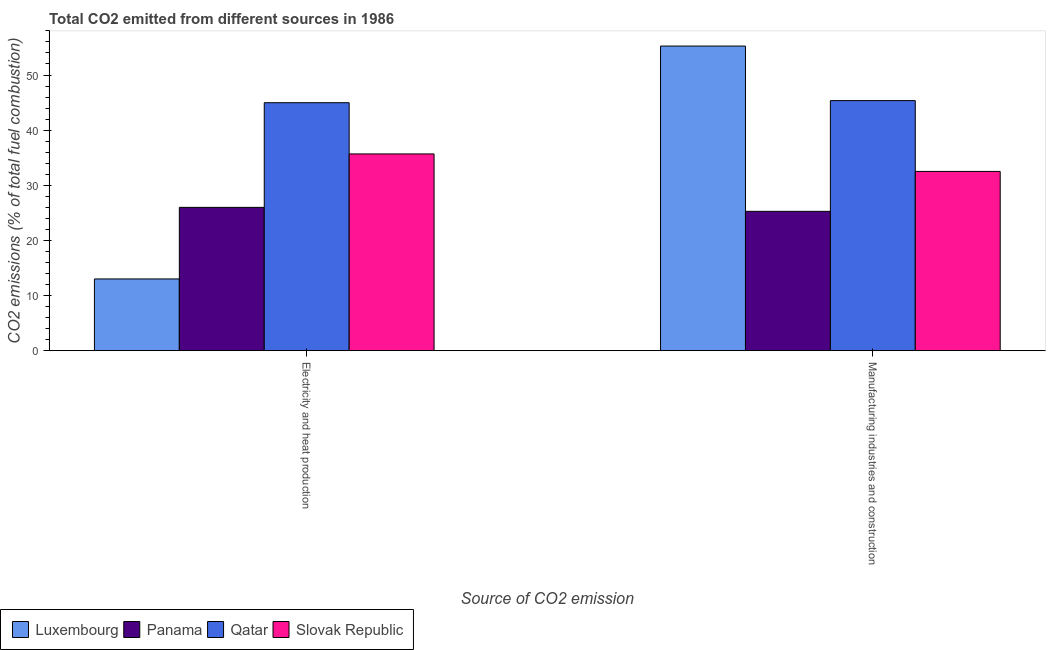How many different coloured bars are there?
Provide a succinct answer. 4. How many groups of bars are there?
Keep it short and to the point. 2. Are the number of bars per tick equal to the number of legend labels?
Ensure brevity in your answer.  Yes. What is the label of the 1st group of bars from the left?
Ensure brevity in your answer.  Electricity and heat production. What is the co2 emissions due to electricity and heat production in Slovak Republic?
Your response must be concise. 35.69. Across all countries, what is the maximum co2 emissions due to electricity and heat production?
Make the answer very short. 44.98. Across all countries, what is the minimum co2 emissions due to electricity and heat production?
Keep it short and to the point. 13.01. In which country was the co2 emissions due to electricity and heat production maximum?
Offer a terse response. Qatar. In which country was the co2 emissions due to electricity and heat production minimum?
Keep it short and to the point. Luxembourg. What is the total co2 emissions due to manufacturing industries in the graph?
Ensure brevity in your answer.  158.4. What is the difference between the co2 emissions due to manufacturing industries in Qatar and that in Panama?
Your response must be concise. 20.09. What is the difference between the co2 emissions due to manufacturing industries in Luxembourg and the co2 emissions due to electricity and heat production in Slovak Republic?
Your answer should be very brief. 19.57. What is the average co2 emissions due to manufacturing industries per country?
Offer a very short reply. 39.6. What is the difference between the co2 emissions due to electricity and heat production and co2 emissions due to manufacturing industries in Qatar?
Your answer should be compact. -0.38. In how many countries, is the co2 emissions due to manufacturing industries greater than 16 %?
Keep it short and to the point. 4. What is the ratio of the co2 emissions due to electricity and heat production in Panama to that in Luxembourg?
Keep it short and to the point. 2. In how many countries, is the co2 emissions due to electricity and heat production greater than the average co2 emissions due to electricity and heat production taken over all countries?
Offer a terse response. 2. What does the 4th bar from the left in Electricity and heat production represents?
Your answer should be compact. Slovak Republic. What does the 3rd bar from the right in Electricity and heat production represents?
Your response must be concise. Panama. How many bars are there?
Your response must be concise. 8. Are all the bars in the graph horizontal?
Provide a succinct answer. No. Does the graph contain grids?
Provide a short and direct response. No. Where does the legend appear in the graph?
Provide a short and direct response. Bottom left. What is the title of the graph?
Provide a succinct answer. Total CO2 emitted from different sources in 1986. What is the label or title of the X-axis?
Your answer should be very brief. Source of CO2 emission. What is the label or title of the Y-axis?
Provide a short and direct response. CO2 emissions (% of total fuel combustion). What is the CO2 emissions (% of total fuel combustion) of Luxembourg in Electricity and heat production?
Keep it short and to the point. 13.01. What is the CO2 emissions (% of total fuel combustion) of Panama in Electricity and heat production?
Provide a short and direct response. 25.99. What is the CO2 emissions (% of total fuel combustion) of Qatar in Electricity and heat production?
Provide a short and direct response. 44.98. What is the CO2 emissions (% of total fuel combustion) in Slovak Republic in Electricity and heat production?
Provide a succinct answer. 35.69. What is the CO2 emissions (% of total fuel combustion) in Luxembourg in Manufacturing industries and construction?
Your answer should be very brief. 55.25. What is the CO2 emissions (% of total fuel combustion) in Panama in Manufacturing industries and construction?
Offer a terse response. 25.27. What is the CO2 emissions (% of total fuel combustion) of Qatar in Manufacturing industries and construction?
Give a very brief answer. 45.36. What is the CO2 emissions (% of total fuel combustion) of Slovak Republic in Manufacturing industries and construction?
Make the answer very short. 32.51. Across all Source of CO2 emission, what is the maximum CO2 emissions (% of total fuel combustion) of Luxembourg?
Give a very brief answer. 55.25. Across all Source of CO2 emission, what is the maximum CO2 emissions (% of total fuel combustion) of Panama?
Give a very brief answer. 25.99. Across all Source of CO2 emission, what is the maximum CO2 emissions (% of total fuel combustion) in Qatar?
Your answer should be compact. 45.36. Across all Source of CO2 emission, what is the maximum CO2 emissions (% of total fuel combustion) of Slovak Republic?
Give a very brief answer. 35.69. Across all Source of CO2 emission, what is the minimum CO2 emissions (% of total fuel combustion) in Luxembourg?
Keep it short and to the point. 13.01. Across all Source of CO2 emission, what is the minimum CO2 emissions (% of total fuel combustion) of Panama?
Your response must be concise. 25.27. Across all Source of CO2 emission, what is the minimum CO2 emissions (% of total fuel combustion) in Qatar?
Keep it short and to the point. 44.98. Across all Source of CO2 emission, what is the minimum CO2 emissions (% of total fuel combustion) in Slovak Republic?
Provide a succinct answer. 32.51. What is the total CO2 emissions (% of total fuel combustion) in Luxembourg in the graph?
Keep it short and to the point. 68.26. What is the total CO2 emissions (% of total fuel combustion) in Panama in the graph?
Make the answer very short. 51.26. What is the total CO2 emissions (% of total fuel combustion) of Qatar in the graph?
Provide a succinct answer. 90.33. What is the total CO2 emissions (% of total fuel combustion) of Slovak Republic in the graph?
Your answer should be very brief. 68.2. What is the difference between the CO2 emissions (% of total fuel combustion) of Luxembourg in Electricity and heat production and that in Manufacturing industries and construction?
Your response must be concise. -42.25. What is the difference between the CO2 emissions (% of total fuel combustion) in Panama in Electricity and heat production and that in Manufacturing industries and construction?
Offer a very short reply. 0.72. What is the difference between the CO2 emissions (% of total fuel combustion) of Qatar in Electricity and heat production and that in Manufacturing industries and construction?
Offer a very short reply. -0.38. What is the difference between the CO2 emissions (% of total fuel combustion) of Slovak Republic in Electricity and heat production and that in Manufacturing industries and construction?
Give a very brief answer. 3.17. What is the difference between the CO2 emissions (% of total fuel combustion) of Luxembourg in Electricity and heat production and the CO2 emissions (% of total fuel combustion) of Panama in Manufacturing industries and construction?
Ensure brevity in your answer.  -12.26. What is the difference between the CO2 emissions (% of total fuel combustion) in Luxembourg in Electricity and heat production and the CO2 emissions (% of total fuel combustion) in Qatar in Manufacturing industries and construction?
Your answer should be very brief. -32.35. What is the difference between the CO2 emissions (% of total fuel combustion) in Luxembourg in Electricity and heat production and the CO2 emissions (% of total fuel combustion) in Slovak Republic in Manufacturing industries and construction?
Your response must be concise. -19.51. What is the difference between the CO2 emissions (% of total fuel combustion) of Panama in Electricity and heat production and the CO2 emissions (% of total fuel combustion) of Qatar in Manufacturing industries and construction?
Make the answer very short. -19.36. What is the difference between the CO2 emissions (% of total fuel combustion) in Panama in Electricity and heat production and the CO2 emissions (% of total fuel combustion) in Slovak Republic in Manufacturing industries and construction?
Your answer should be compact. -6.52. What is the difference between the CO2 emissions (% of total fuel combustion) in Qatar in Electricity and heat production and the CO2 emissions (% of total fuel combustion) in Slovak Republic in Manufacturing industries and construction?
Provide a short and direct response. 12.46. What is the average CO2 emissions (% of total fuel combustion) in Luxembourg per Source of CO2 emission?
Keep it short and to the point. 34.13. What is the average CO2 emissions (% of total fuel combustion) in Panama per Source of CO2 emission?
Give a very brief answer. 25.63. What is the average CO2 emissions (% of total fuel combustion) of Qatar per Source of CO2 emission?
Offer a terse response. 45.17. What is the average CO2 emissions (% of total fuel combustion) in Slovak Republic per Source of CO2 emission?
Keep it short and to the point. 34.1. What is the difference between the CO2 emissions (% of total fuel combustion) in Luxembourg and CO2 emissions (% of total fuel combustion) in Panama in Electricity and heat production?
Ensure brevity in your answer.  -12.99. What is the difference between the CO2 emissions (% of total fuel combustion) in Luxembourg and CO2 emissions (% of total fuel combustion) in Qatar in Electricity and heat production?
Provide a short and direct response. -31.97. What is the difference between the CO2 emissions (% of total fuel combustion) in Luxembourg and CO2 emissions (% of total fuel combustion) in Slovak Republic in Electricity and heat production?
Provide a succinct answer. -22.68. What is the difference between the CO2 emissions (% of total fuel combustion) in Panama and CO2 emissions (% of total fuel combustion) in Qatar in Electricity and heat production?
Offer a terse response. -18.98. What is the difference between the CO2 emissions (% of total fuel combustion) of Panama and CO2 emissions (% of total fuel combustion) of Slovak Republic in Electricity and heat production?
Ensure brevity in your answer.  -9.69. What is the difference between the CO2 emissions (% of total fuel combustion) of Qatar and CO2 emissions (% of total fuel combustion) of Slovak Republic in Electricity and heat production?
Provide a succinct answer. 9.29. What is the difference between the CO2 emissions (% of total fuel combustion) of Luxembourg and CO2 emissions (% of total fuel combustion) of Panama in Manufacturing industries and construction?
Your answer should be compact. 29.98. What is the difference between the CO2 emissions (% of total fuel combustion) in Luxembourg and CO2 emissions (% of total fuel combustion) in Qatar in Manufacturing industries and construction?
Offer a terse response. 9.9. What is the difference between the CO2 emissions (% of total fuel combustion) in Luxembourg and CO2 emissions (% of total fuel combustion) in Slovak Republic in Manufacturing industries and construction?
Your answer should be compact. 22.74. What is the difference between the CO2 emissions (% of total fuel combustion) in Panama and CO2 emissions (% of total fuel combustion) in Qatar in Manufacturing industries and construction?
Offer a terse response. -20.09. What is the difference between the CO2 emissions (% of total fuel combustion) in Panama and CO2 emissions (% of total fuel combustion) in Slovak Republic in Manufacturing industries and construction?
Your response must be concise. -7.24. What is the difference between the CO2 emissions (% of total fuel combustion) in Qatar and CO2 emissions (% of total fuel combustion) in Slovak Republic in Manufacturing industries and construction?
Offer a very short reply. 12.84. What is the ratio of the CO2 emissions (% of total fuel combustion) of Luxembourg in Electricity and heat production to that in Manufacturing industries and construction?
Give a very brief answer. 0.24. What is the ratio of the CO2 emissions (% of total fuel combustion) in Panama in Electricity and heat production to that in Manufacturing industries and construction?
Your response must be concise. 1.03. What is the ratio of the CO2 emissions (% of total fuel combustion) in Qatar in Electricity and heat production to that in Manufacturing industries and construction?
Your response must be concise. 0.99. What is the ratio of the CO2 emissions (% of total fuel combustion) of Slovak Republic in Electricity and heat production to that in Manufacturing industries and construction?
Your answer should be compact. 1.1. What is the difference between the highest and the second highest CO2 emissions (% of total fuel combustion) of Luxembourg?
Provide a short and direct response. 42.25. What is the difference between the highest and the second highest CO2 emissions (% of total fuel combustion) in Panama?
Keep it short and to the point. 0.72. What is the difference between the highest and the second highest CO2 emissions (% of total fuel combustion) of Qatar?
Make the answer very short. 0.38. What is the difference between the highest and the second highest CO2 emissions (% of total fuel combustion) in Slovak Republic?
Ensure brevity in your answer.  3.17. What is the difference between the highest and the lowest CO2 emissions (% of total fuel combustion) of Luxembourg?
Make the answer very short. 42.25. What is the difference between the highest and the lowest CO2 emissions (% of total fuel combustion) of Panama?
Provide a succinct answer. 0.72. What is the difference between the highest and the lowest CO2 emissions (% of total fuel combustion) of Qatar?
Your answer should be very brief. 0.38. What is the difference between the highest and the lowest CO2 emissions (% of total fuel combustion) in Slovak Republic?
Ensure brevity in your answer.  3.17. 